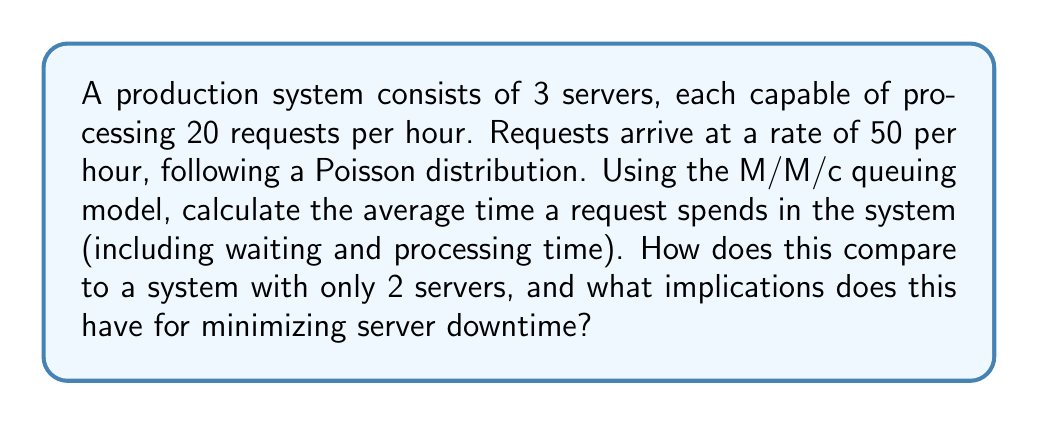Could you help me with this problem? To solve this problem, we'll use the M/M/c queuing model, where M/M/c represents Markovian arrival/Markovian service time/c servers.

Given:
- Arrival rate (λ) = 50 requests/hour
- Service rate per server (μ) = 20 requests/hour
- Number of servers (c) = 3

Step 1: Calculate the utilization factor (ρ)
$$\rho = \frac{\lambda}{c\mu} = \frac{50}{3 \cdot 20} = \frac{5}{6} \approx 0.833$$

Step 2: Calculate P0 (probability of an empty system)
$$P_0 = \left[\sum_{n=0}^{c-1}\frac{(c\rho)^n}{n!} + \frac{(c\rho)^c}{c!(1-\rho)}\right]^{-1}$$

$$P_0 = \left[1 + \frac{50}{20} + \frac{50^2}{2 \cdot 20^2} + \frac{50^3}{6 \cdot 20^3 \cdot (1-\frac{5}{6})}\right]^{-1} \approx 0.0398$$

Step 3: Calculate Lq (average number of requests in the queue)
$$L_q = \frac{P_0(c\rho)^c\rho}{c!(1-\rho)^2} = \frac{0.0398 \cdot 50^3}{6 \cdot 20^3 \cdot (1-\frac{5}{6})^2} \approx 2.0833$$

Step 4: Calculate W (average time a request spends in the system)
$$W = \frac{L_q}{\lambda} + \frac{1}{\mu} = \frac{2.0833}{50} + \frac{1}{20} = 0.09167 \text{ hours} = 5.5 \text{ minutes}$$

For comparison, let's calculate the same for a 2-server system:
ρ = 50 / (2 * 20) = 1.25 (unstable system, as ρ > 1)

In a 2-server system, the arrival rate exceeds the total service rate, leading to an unstable system where the queue would grow indefinitely. This would result in extremely long wait times and potential system crashes.

The 3-server system provides stability and reasonable wait times, which helps minimize server downtime by preventing overload and allowing for maintenance windows without significantly impacting performance.
Answer: The average time a request spends in the 3-server system is approximately 5.5 minutes. This is significantly better than a 2-server system, which would be unstable and lead to indefinite queue growth. The 3-server configuration helps minimize server downtime by providing a stable system with manageable wait times, allowing for better resource allocation and maintenance scheduling. 